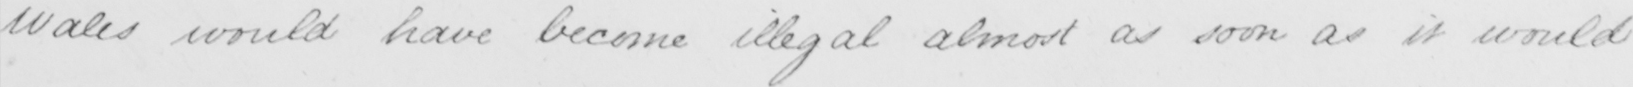Can you read and transcribe this handwriting? Wales would have become illegal almost as soon as it would 